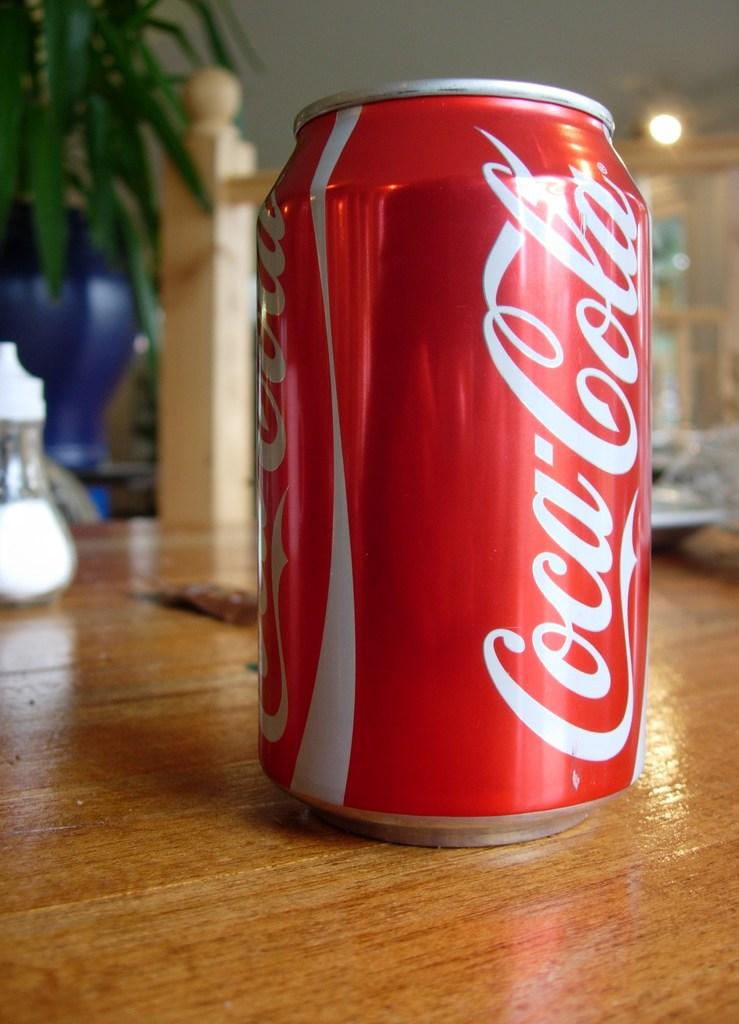Provide a one-sentence caption for the provided image. A can of Coca Cola sits on a wooden table. 